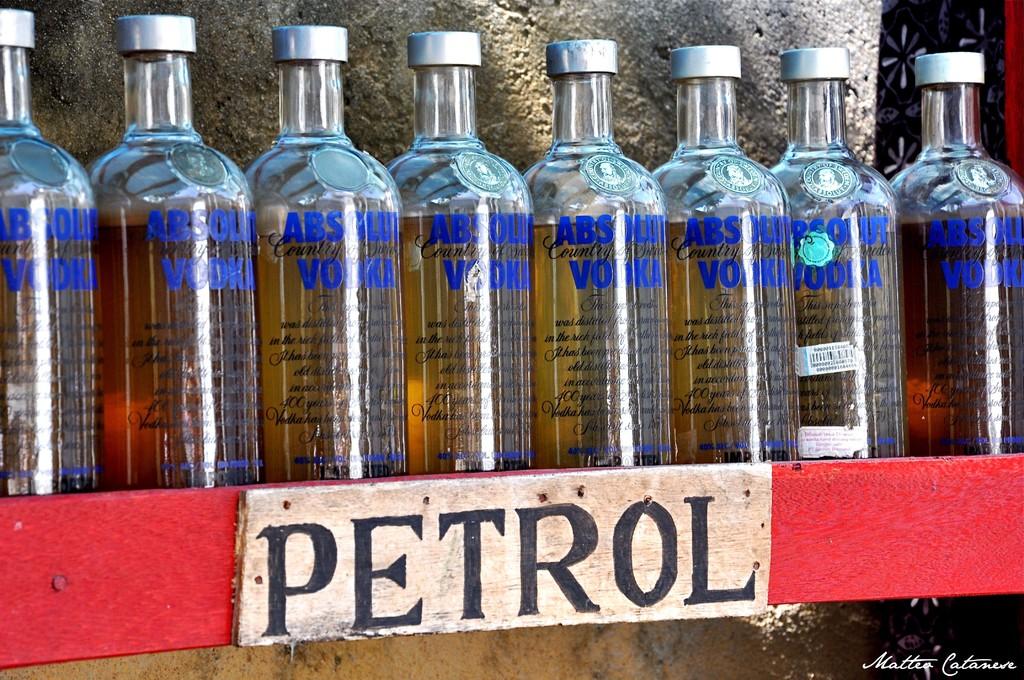What is written on the wooden board?
Provide a short and direct response. Petrol. Do the bottles all say absolut vodka?
Your answer should be very brief. Yes. 